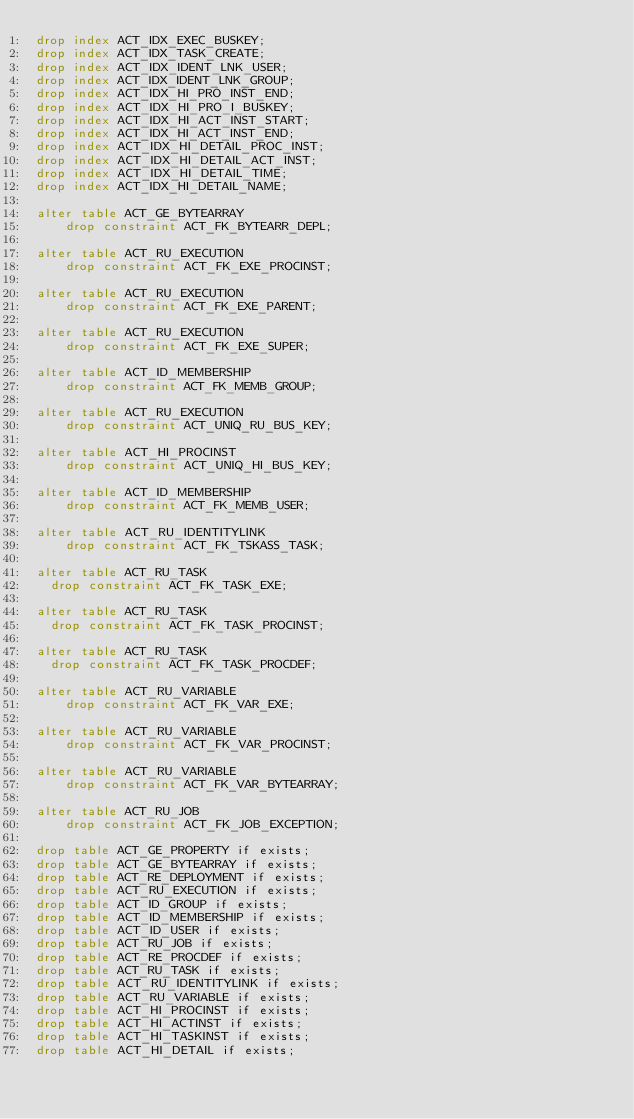<code> <loc_0><loc_0><loc_500><loc_500><_SQL_>drop index ACT_IDX_EXEC_BUSKEY;
drop index ACT_IDX_TASK_CREATE;
drop index ACT_IDX_IDENT_LNK_USER;
drop index ACT_IDX_IDENT_LNK_GROUP;
drop index ACT_IDX_HI_PRO_INST_END;
drop index ACT_IDX_HI_PRO_I_BUSKEY;
drop index ACT_IDX_HI_ACT_INST_START;
drop index ACT_IDX_HI_ACT_INST_END;
drop index ACT_IDX_HI_DETAIL_PROC_INST;
drop index ACT_IDX_HI_DETAIL_ACT_INST;
drop index ACT_IDX_HI_DETAIL_TIME;
drop index ACT_IDX_HI_DETAIL_NAME;

alter table ACT_GE_BYTEARRAY 
    drop constraint ACT_FK_BYTEARR_DEPL;

alter table ACT_RU_EXECUTION
    drop constraint ACT_FK_EXE_PROCINST;

alter table ACT_RU_EXECUTION 
    drop constraint ACT_FK_EXE_PARENT;

alter table ACT_RU_EXECUTION 
    drop constraint ACT_FK_EXE_SUPER;
    
alter table ACT_ID_MEMBERSHIP 
    drop constraint ACT_FK_MEMB_GROUP;
    
alter table ACT_RU_EXECUTION
    drop constraint ACT_UNIQ_RU_BUS_KEY;
    
alter table ACT_HI_PROCINST
    drop constraint ACT_UNIQ_HI_BUS_KEY;
    
alter table ACT_ID_MEMBERSHIP 
    drop constraint ACT_FK_MEMB_USER;
    
alter table ACT_RU_IDENTITYLINK
    drop constraint ACT_FK_TSKASS_TASK;
 
alter table ACT_RU_TASK
	drop constraint ACT_FK_TASK_EXE;

alter table ACT_RU_TASK
	drop constraint ACT_FK_TASK_PROCINST;
	
alter table ACT_RU_TASK
	drop constraint ACT_FK_TASK_PROCDEF;
	
alter table ACT_RU_VARIABLE
    drop constraint ACT_FK_VAR_EXE;
    
alter table ACT_RU_VARIABLE
    drop constraint ACT_FK_VAR_PROCINST;
    
alter table ACT_RU_VARIABLE
    drop constraint ACT_FK_VAR_BYTEARRAY;

alter table ACT_RU_JOB
    drop constraint ACT_FK_JOB_EXCEPTION;
    
drop table ACT_GE_PROPERTY if exists;
drop table ACT_GE_BYTEARRAY if exists;
drop table ACT_RE_DEPLOYMENT if exists;
drop table ACT_RU_EXECUTION if exists;
drop table ACT_ID_GROUP if exists;
drop table ACT_ID_MEMBERSHIP if exists;
drop table ACT_ID_USER if exists;
drop table ACT_RU_JOB if exists;
drop table ACT_RE_PROCDEF if exists;
drop table ACT_RU_TASK if exists;
drop table ACT_RU_IDENTITYLINK if exists;
drop table ACT_RU_VARIABLE if exists;
drop table ACT_HI_PROCINST if exists;
drop table ACT_HI_ACTINST if exists;
drop table ACT_HI_TASKINST if exists;
drop table ACT_HI_DETAIL if exists;
</code> 